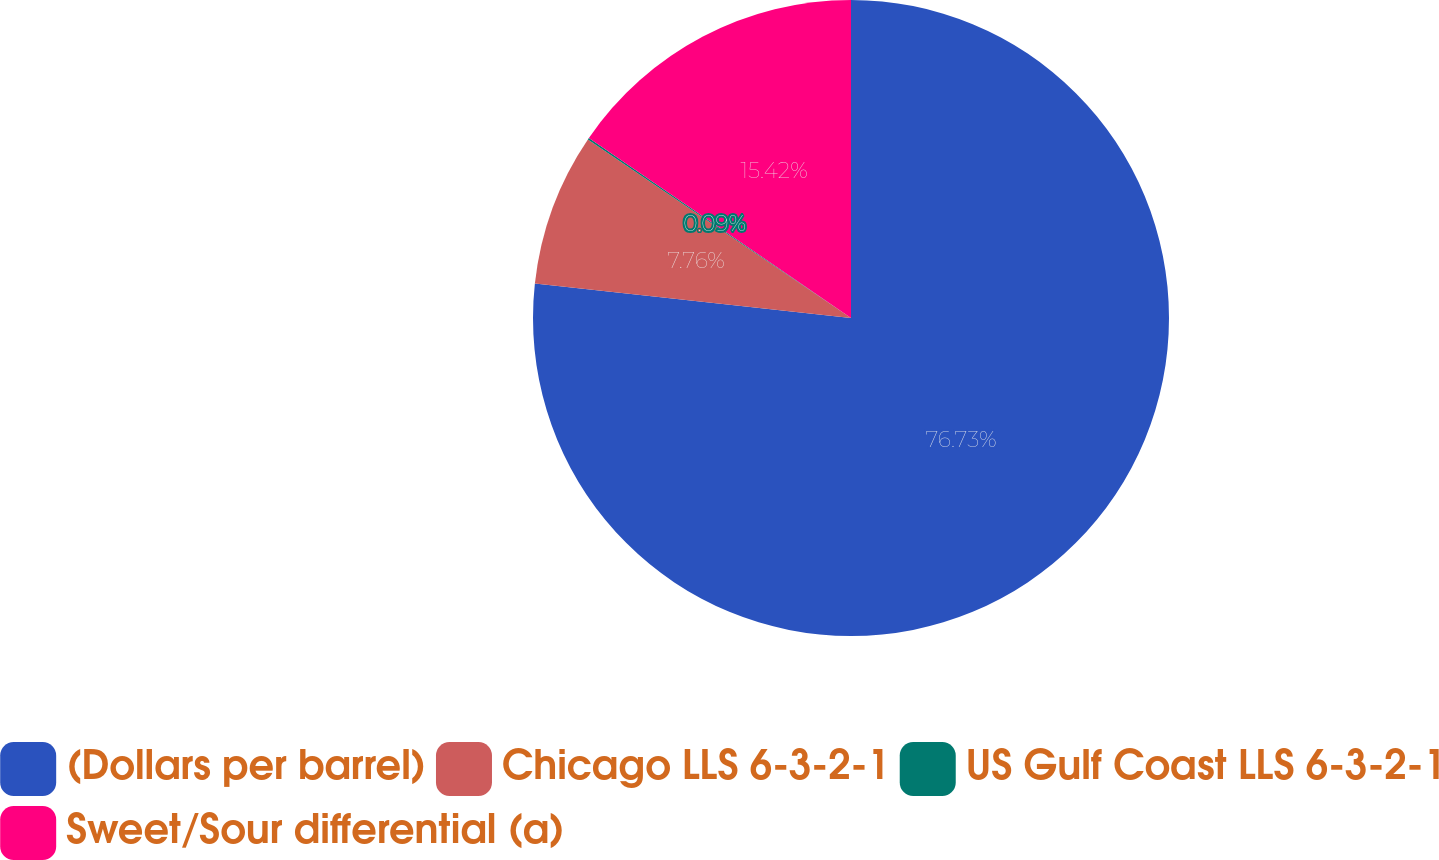<chart> <loc_0><loc_0><loc_500><loc_500><pie_chart><fcel>(Dollars per barrel)<fcel>Chicago LLS 6-3-2-1<fcel>US Gulf Coast LLS 6-3-2-1<fcel>Sweet/Sour differential (a)<nl><fcel>76.73%<fcel>7.76%<fcel>0.09%<fcel>15.42%<nl></chart> 